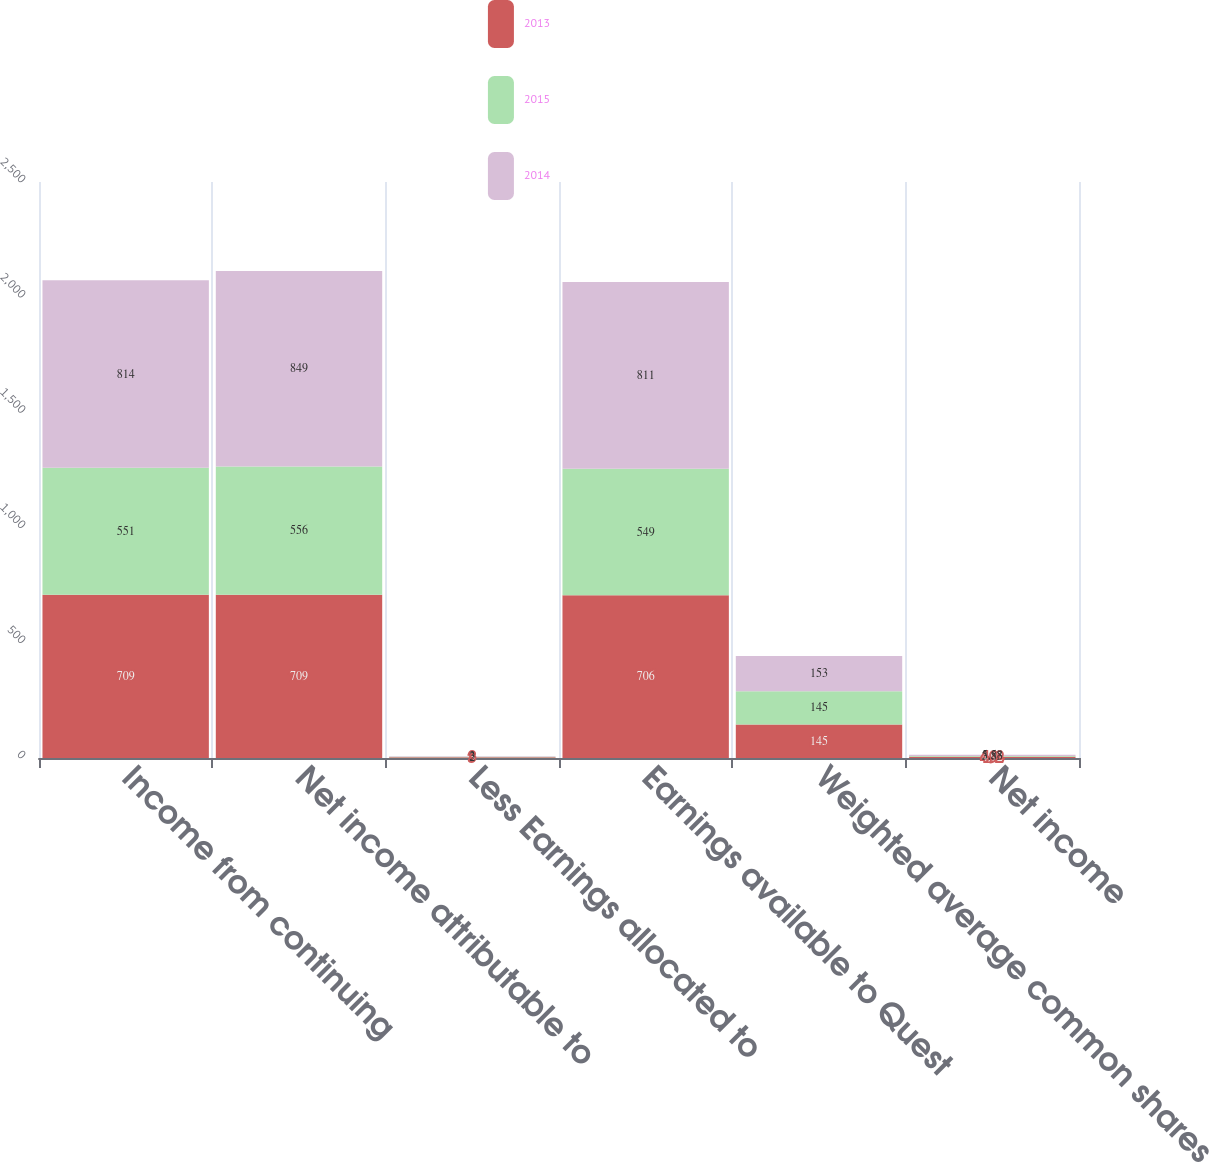Convert chart. <chart><loc_0><loc_0><loc_500><loc_500><stacked_bar_chart><ecel><fcel>Income from continuing<fcel>Net income attributable to<fcel>Less Earnings allocated to<fcel>Earnings available to Quest<fcel>Weighted average common shares<fcel>Net income<nl><fcel>2013<fcel>709<fcel>709<fcel>3<fcel>706<fcel>145<fcel>4.92<nl><fcel>2015<fcel>551<fcel>556<fcel>2<fcel>549<fcel>145<fcel>3.83<nl><fcel>2014<fcel>814<fcel>849<fcel>3<fcel>811<fcel>153<fcel>5.58<nl></chart> 